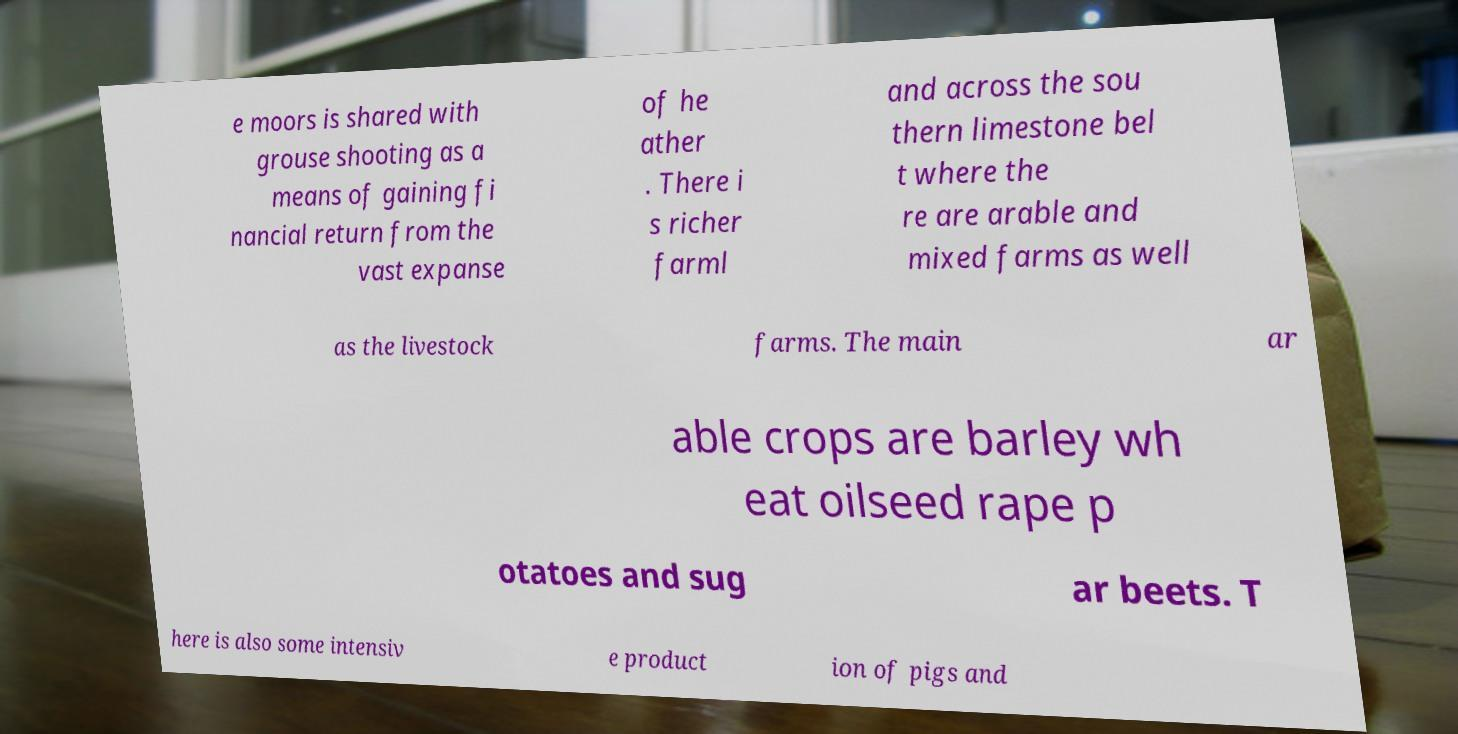Can you read and provide the text displayed in the image?This photo seems to have some interesting text. Can you extract and type it out for me? e moors is shared with grouse shooting as a means of gaining fi nancial return from the vast expanse of he ather . There i s richer farml and across the sou thern limestone bel t where the re are arable and mixed farms as well as the livestock farms. The main ar able crops are barley wh eat oilseed rape p otatoes and sug ar beets. T here is also some intensiv e product ion of pigs and 